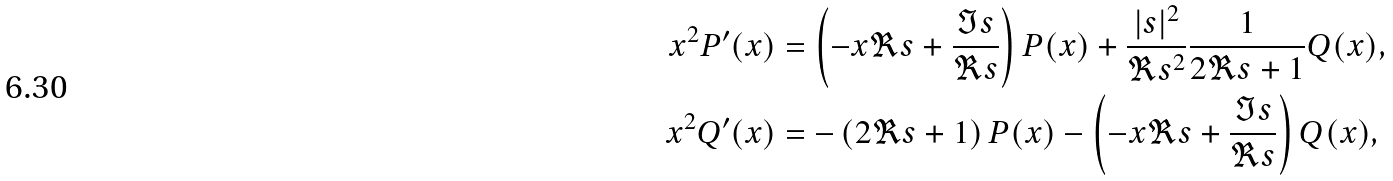Convert formula to latex. <formula><loc_0><loc_0><loc_500><loc_500>x ^ { 2 } P ^ { \prime } ( x ) & = \left ( - x \Re { s } + \frac { \Im { s } } { \Re { s } } \right ) P ( x ) + \frac { | s | ^ { 2 } } { \Re { s } ^ { 2 } } \frac { 1 } { 2 \Re { s } + 1 } Q ( x ) , \\ x ^ { 2 } Q ^ { \prime } ( x ) & = - \left ( 2 \Re { s } + 1 \right ) P ( x ) - \left ( - x \Re { s } + \frac { \Im { s } } { \Re { s } } \right ) Q ( x ) ,</formula> 